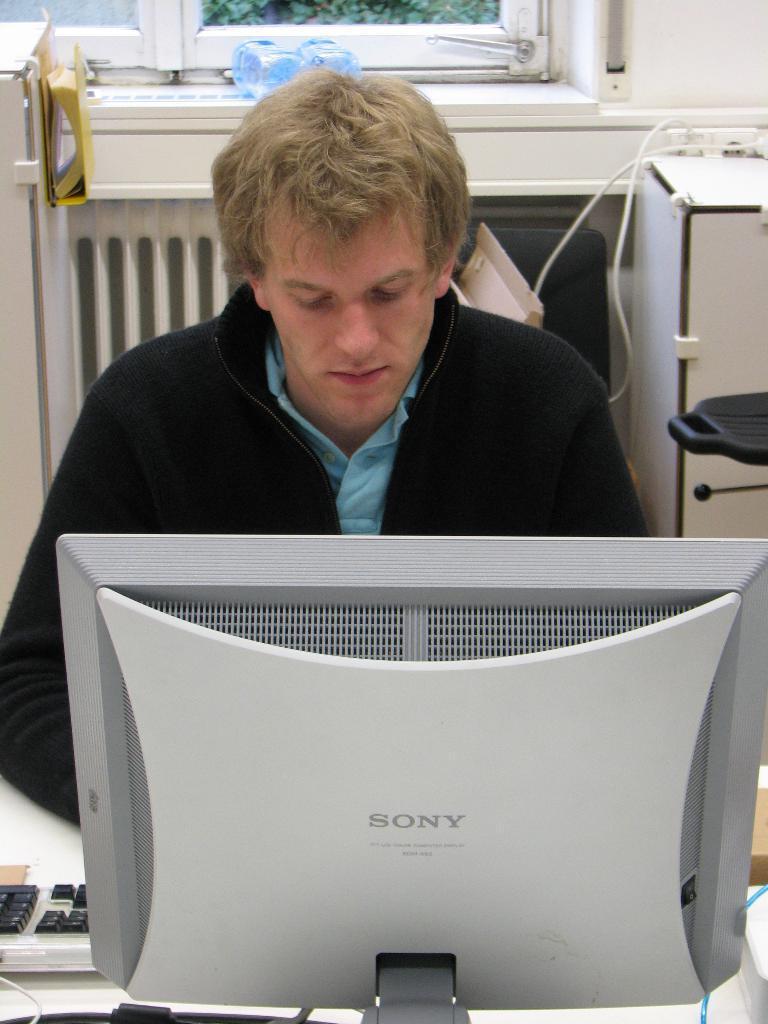Can you describe this image briefly? This is the picture of a room. In this image there is a person sitting behind the table. There is a computer, keyboard on the table. At the back there is a table, cupboard and there are bottles on the wall. There is a window, there are plants outside the window. 